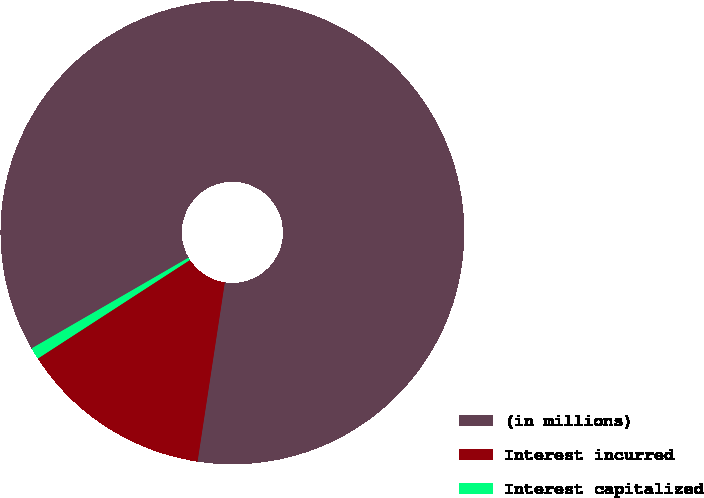Convert chart to OTSL. <chart><loc_0><loc_0><loc_500><loc_500><pie_chart><fcel>(in millions)<fcel>Interest incurred<fcel>Interest capitalized<nl><fcel>85.74%<fcel>13.44%<fcel>0.81%<nl></chart> 